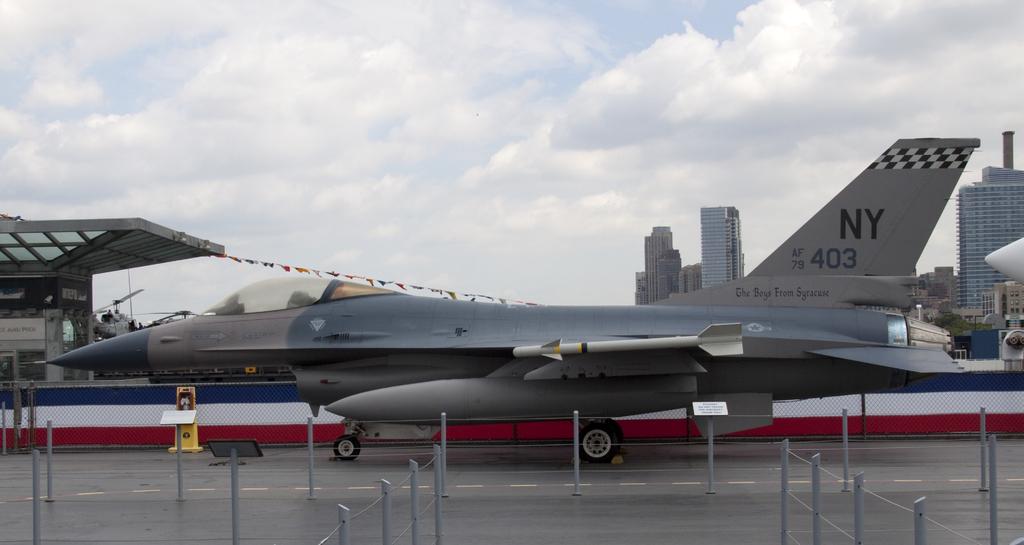What state is this plane from?
Your response must be concise. Ny. What are the letters on the tail of the plane?
Your answer should be very brief. Ny. 